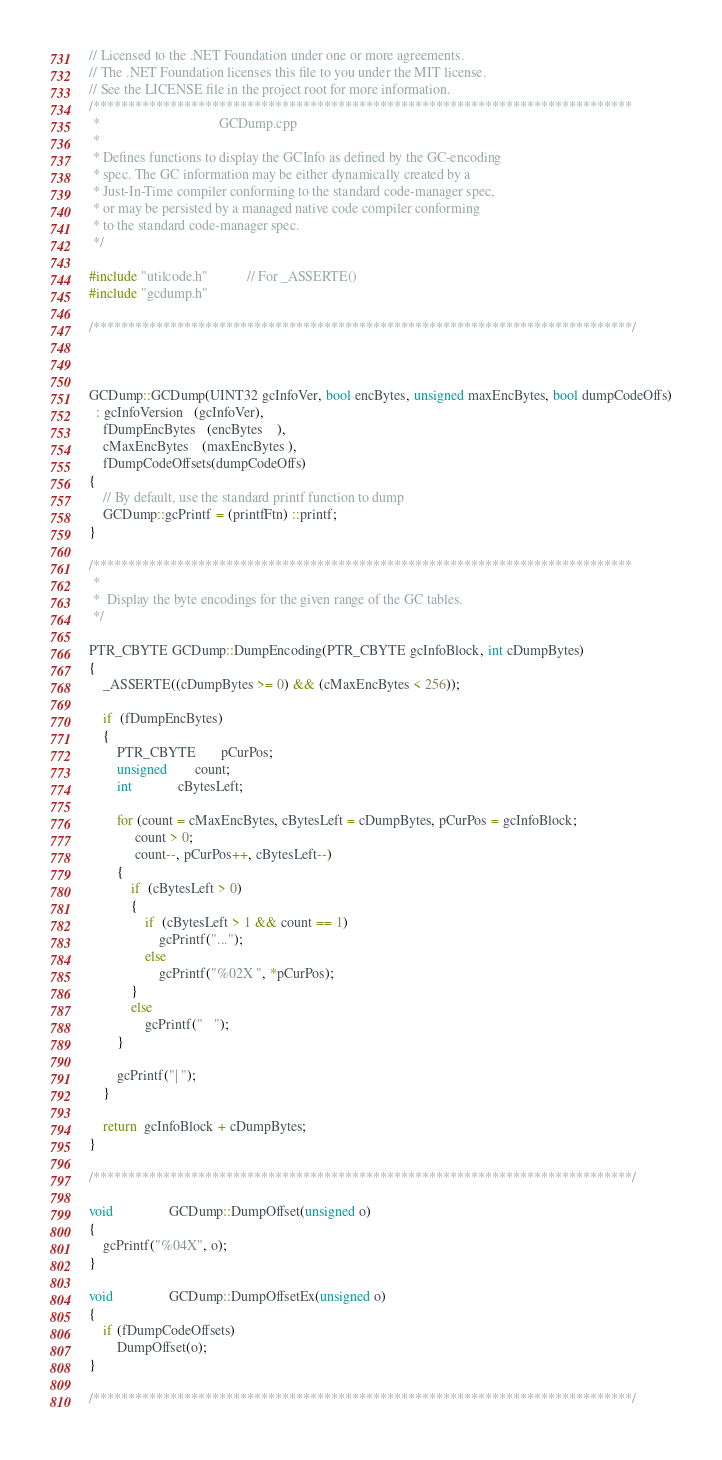<code> <loc_0><loc_0><loc_500><loc_500><_C++_>// Licensed to the .NET Foundation under one or more agreements.
// The .NET Foundation licenses this file to you under the MIT license.
// See the LICENSE file in the project root for more information.
/*****************************************************************************
 *                                  GCDump.cpp
 *
 * Defines functions to display the GCInfo as defined by the GC-encoding 
 * spec. The GC information may be either dynamically created by a 
 * Just-In-Time compiler conforming to the standard code-manager spec,
 * or may be persisted by a managed native code compiler conforming
 * to the standard code-manager spec.
 */

#include "utilcode.h"           // For _ASSERTE()
#include "gcdump.h"

/*****************************************************************************/



GCDump::GCDump(UINT32 gcInfoVer, bool encBytes, unsigned maxEncBytes, bool dumpCodeOffs)
  : gcInfoVersion   (gcInfoVer),
    fDumpEncBytes   (encBytes    ), 
    cMaxEncBytes    (maxEncBytes ), 
    fDumpCodeOffsets(dumpCodeOffs)
{
    // By default, use the standard printf function to dump 
    GCDump::gcPrintf = (printfFtn) ::printf;
}

/*****************************************************************************
 *
 *  Display the byte encodings for the given range of the GC tables.
 */

PTR_CBYTE GCDump::DumpEncoding(PTR_CBYTE gcInfoBlock, int cDumpBytes)
{
    _ASSERTE((cDumpBytes >= 0) && (cMaxEncBytes < 256));

    if  (fDumpEncBytes)
    {
        PTR_CBYTE       pCurPos;
        unsigned        count;
        int             cBytesLeft;

        for (count = cMaxEncBytes, cBytesLeft = cDumpBytes, pCurPos = gcInfoBlock;
             count > 0; 
             count--, pCurPos++, cBytesLeft--)
        {
            if  (cBytesLeft > 0)
            {
                if  (cBytesLeft > 1 && count == 1)
                    gcPrintf("...");
                else
                    gcPrintf("%02X ", *pCurPos);
            }
            else
                gcPrintf("   ");
        }

        gcPrintf("| ");
    }

    return  gcInfoBlock + cDumpBytes;
}

/*****************************************************************************/

void                GCDump::DumpOffset(unsigned o)
{
    gcPrintf("%04X", o);
}

void                GCDump::DumpOffsetEx(unsigned o)
{
    if (fDumpCodeOffsets) 
        DumpOffset(o);
}

/*****************************************************************************/
</code> 